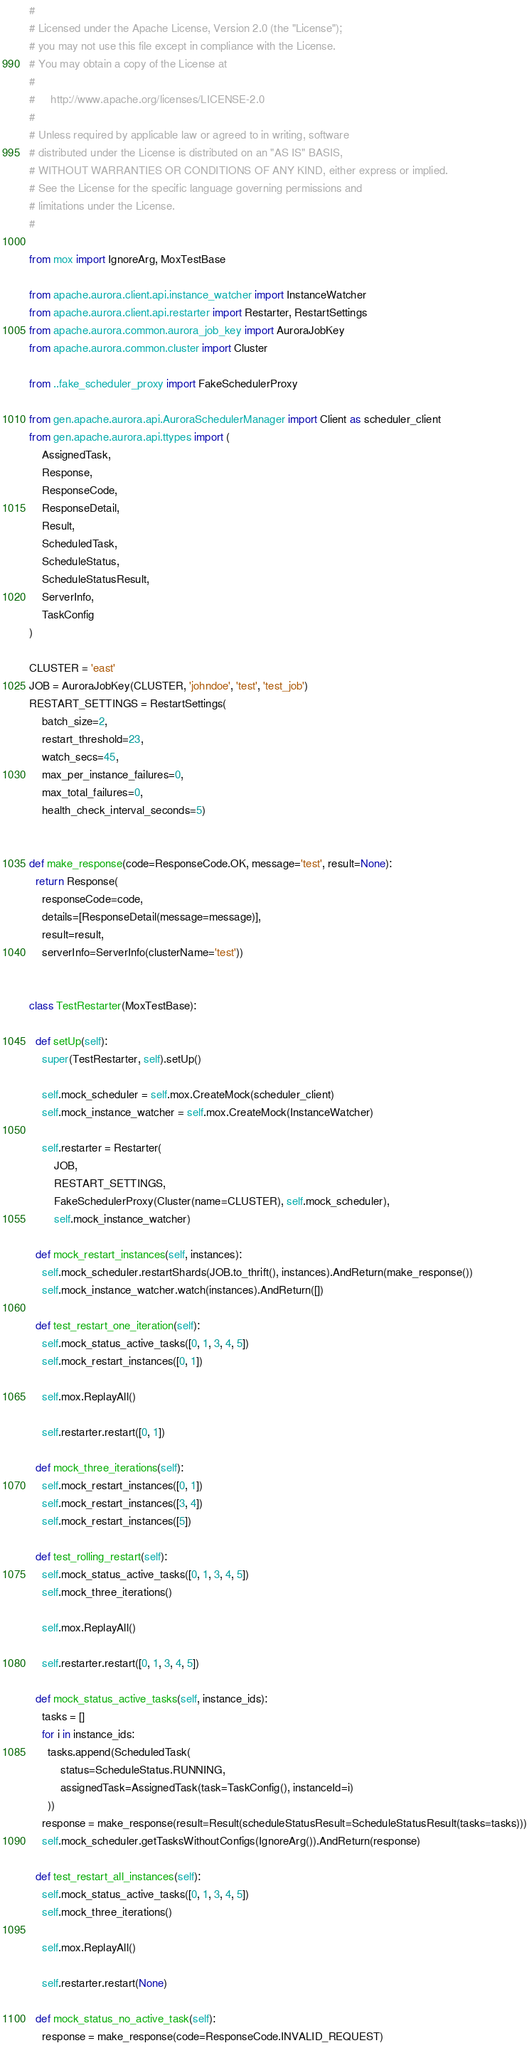Convert code to text. <code><loc_0><loc_0><loc_500><loc_500><_Python_>#
# Licensed under the Apache License, Version 2.0 (the "License");
# you may not use this file except in compliance with the License.
# You may obtain a copy of the License at
#
#     http://www.apache.org/licenses/LICENSE-2.0
#
# Unless required by applicable law or agreed to in writing, software
# distributed under the License is distributed on an "AS IS" BASIS,
# WITHOUT WARRANTIES OR CONDITIONS OF ANY KIND, either express or implied.
# See the License for the specific language governing permissions and
# limitations under the License.
#

from mox import IgnoreArg, MoxTestBase

from apache.aurora.client.api.instance_watcher import InstanceWatcher
from apache.aurora.client.api.restarter import Restarter, RestartSettings
from apache.aurora.common.aurora_job_key import AuroraJobKey
from apache.aurora.common.cluster import Cluster

from ..fake_scheduler_proxy import FakeSchedulerProxy

from gen.apache.aurora.api.AuroraSchedulerManager import Client as scheduler_client
from gen.apache.aurora.api.ttypes import (
    AssignedTask,
    Response,
    ResponseCode,
    ResponseDetail,
    Result,
    ScheduledTask,
    ScheduleStatus,
    ScheduleStatusResult,
    ServerInfo,
    TaskConfig
)

CLUSTER = 'east'
JOB = AuroraJobKey(CLUSTER, 'johndoe', 'test', 'test_job')
RESTART_SETTINGS = RestartSettings(
    batch_size=2,
    restart_threshold=23,
    watch_secs=45,
    max_per_instance_failures=0,
    max_total_failures=0,
    health_check_interval_seconds=5)


def make_response(code=ResponseCode.OK, message='test', result=None):
  return Response(
    responseCode=code,
    details=[ResponseDetail(message=message)],
    result=result,
    serverInfo=ServerInfo(clusterName='test'))


class TestRestarter(MoxTestBase):

  def setUp(self):
    super(TestRestarter, self).setUp()

    self.mock_scheduler = self.mox.CreateMock(scheduler_client)
    self.mock_instance_watcher = self.mox.CreateMock(InstanceWatcher)

    self.restarter = Restarter(
        JOB,
        RESTART_SETTINGS,
        FakeSchedulerProxy(Cluster(name=CLUSTER), self.mock_scheduler),
        self.mock_instance_watcher)

  def mock_restart_instances(self, instances):
    self.mock_scheduler.restartShards(JOB.to_thrift(), instances).AndReturn(make_response())
    self.mock_instance_watcher.watch(instances).AndReturn([])

  def test_restart_one_iteration(self):
    self.mock_status_active_tasks([0, 1, 3, 4, 5])
    self.mock_restart_instances([0, 1])

    self.mox.ReplayAll()

    self.restarter.restart([0, 1])

  def mock_three_iterations(self):
    self.mock_restart_instances([0, 1])
    self.mock_restart_instances([3, 4])
    self.mock_restart_instances([5])

  def test_rolling_restart(self):
    self.mock_status_active_tasks([0, 1, 3, 4, 5])
    self.mock_three_iterations()

    self.mox.ReplayAll()

    self.restarter.restart([0, 1, 3, 4, 5])

  def mock_status_active_tasks(self, instance_ids):
    tasks = []
    for i in instance_ids:
      tasks.append(ScheduledTask(
          status=ScheduleStatus.RUNNING,
          assignedTask=AssignedTask(task=TaskConfig(), instanceId=i)
      ))
    response = make_response(result=Result(scheduleStatusResult=ScheduleStatusResult(tasks=tasks)))
    self.mock_scheduler.getTasksWithoutConfigs(IgnoreArg()).AndReturn(response)

  def test_restart_all_instances(self):
    self.mock_status_active_tasks([0, 1, 3, 4, 5])
    self.mock_three_iterations()

    self.mox.ReplayAll()

    self.restarter.restart(None)

  def mock_status_no_active_task(self):
    response = make_response(code=ResponseCode.INVALID_REQUEST)</code> 